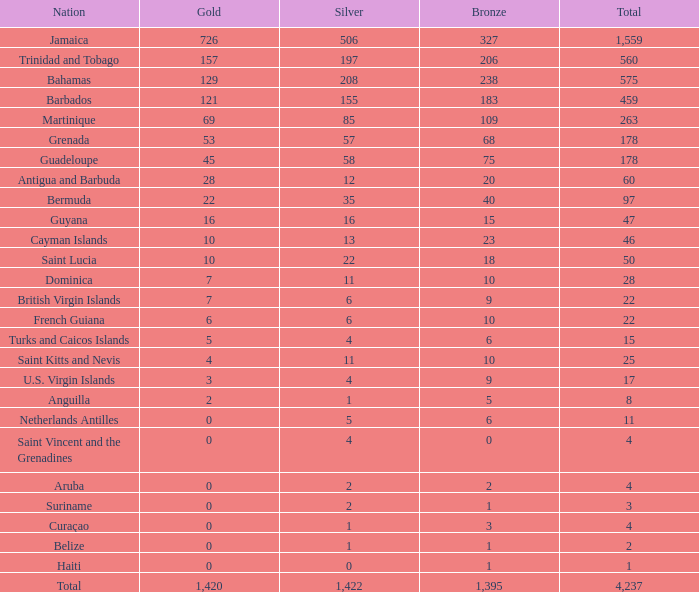What is the combined total of silver less than 560, bronze greater than 6, and gold equal to 3? 4.0. 